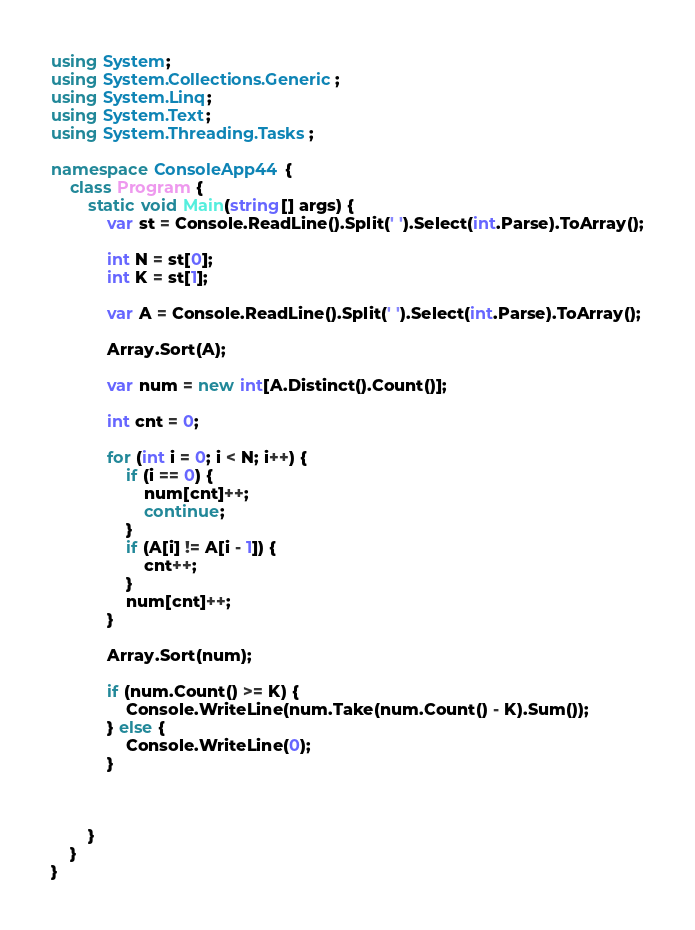Convert code to text. <code><loc_0><loc_0><loc_500><loc_500><_C#_>using System;
using System.Collections.Generic;
using System.Linq;
using System.Text;
using System.Threading.Tasks;

namespace ConsoleApp44 {
    class Program {
        static void Main(string[] args) {
            var st = Console.ReadLine().Split(' ').Select(int.Parse).ToArray();

            int N = st[0];
            int K = st[1];

            var A = Console.ReadLine().Split(' ').Select(int.Parse).ToArray();

            Array.Sort(A);

            var num = new int[A.Distinct().Count()];

            int cnt = 0;

            for (int i = 0; i < N; i++) {
                if (i == 0) {
                    num[cnt]++;
                    continue;
                }
                if (A[i] != A[i - 1]) {
                    cnt++;
                }
                num[cnt]++;
            }

            Array.Sort(num);

            if (num.Count() >= K) {
                Console.WriteLine(num.Take(num.Count() - K).Sum());
            } else {
                Console.WriteLine(0);
            }

            

        }
    }
}
</code> 